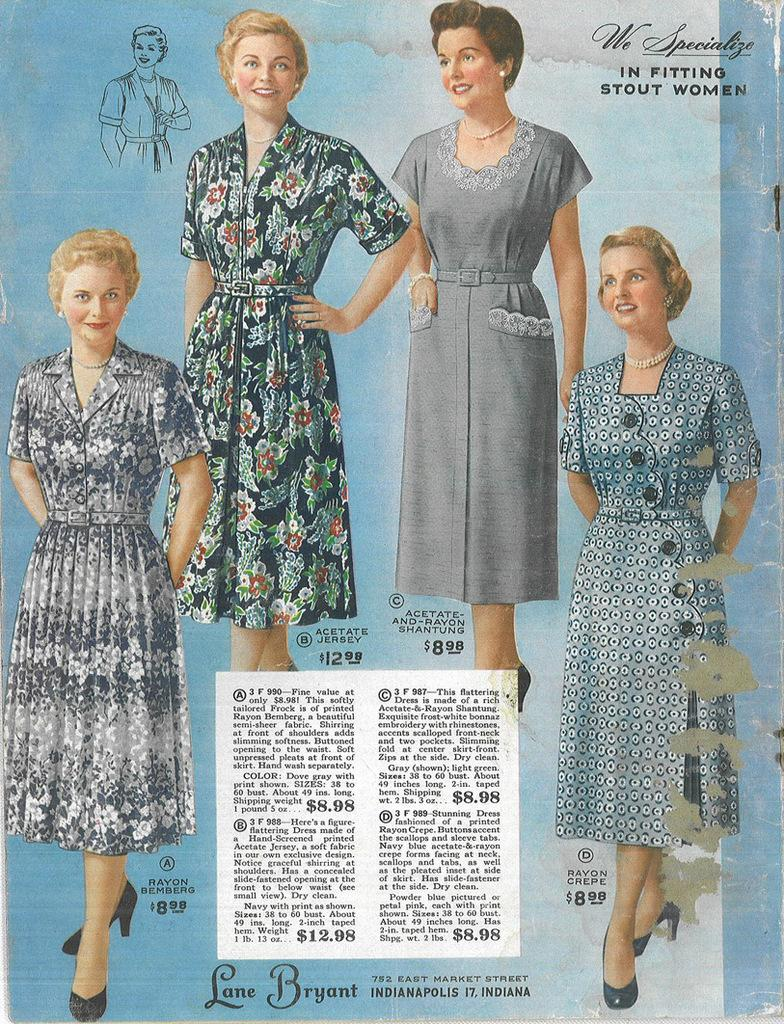What can be seen on the wall in the picture? There is a poster in the picture. What is written on the poster? The poster has text on it. Who is present in the picture? There are women standing in the picture. Where can text be found in the picture besides the poster? There is text at the top right corner and at the bottom of the picture. What type of feast is being prepared in the picture? There is no feast being prepared in the picture; it features a poster and women standing nearby. What color is the sheet draped over the table in the picture? There is no sheet present in the picture. 